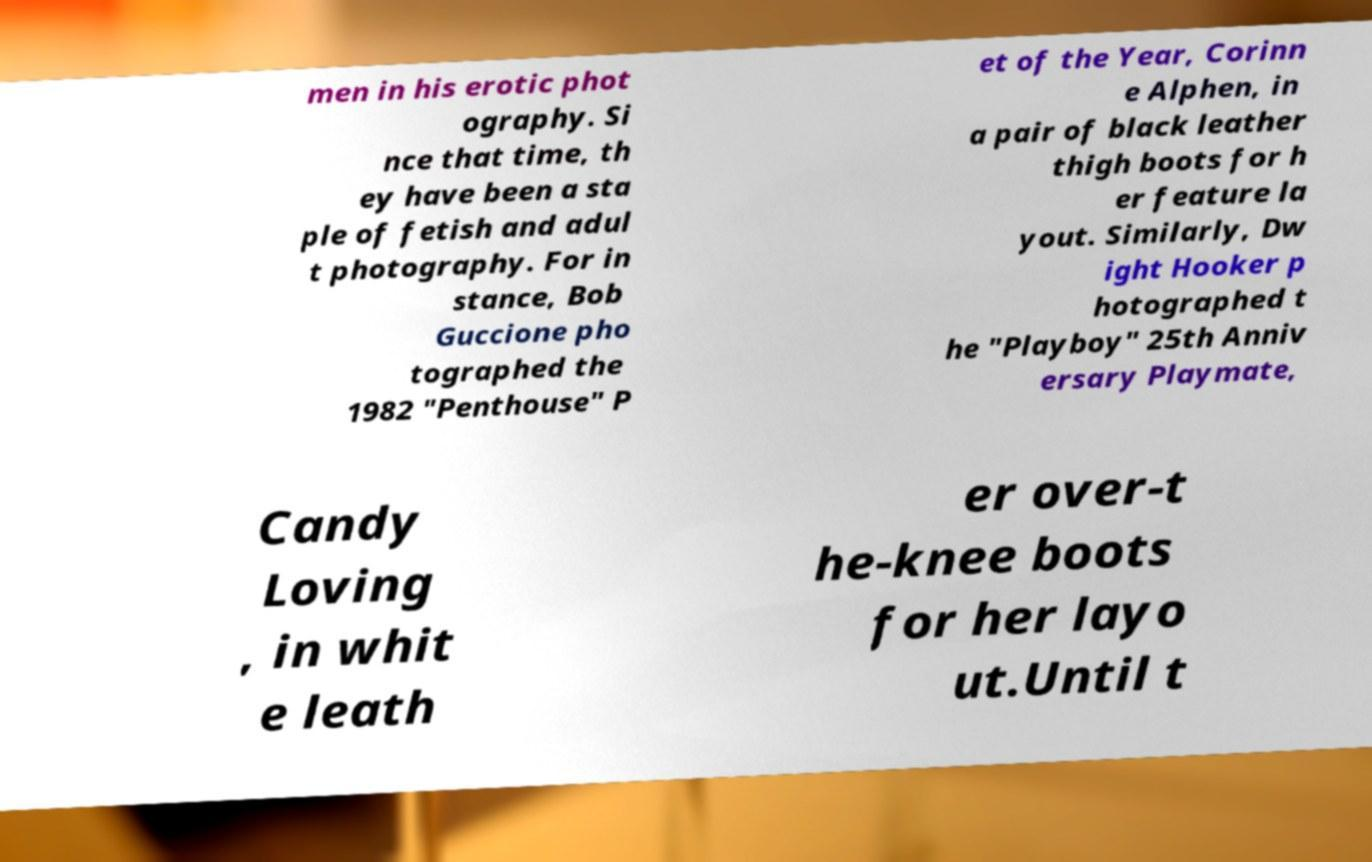Can you accurately transcribe the text from the provided image for me? men in his erotic phot ography. Si nce that time, th ey have been a sta ple of fetish and adul t photography. For in stance, Bob Guccione pho tographed the 1982 "Penthouse" P et of the Year, Corinn e Alphen, in a pair of black leather thigh boots for h er feature la yout. Similarly, Dw ight Hooker p hotographed t he "Playboy" 25th Anniv ersary Playmate, Candy Loving , in whit e leath er over-t he-knee boots for her layo ut.Until t 